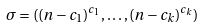Convert formula to latex. <formula><loc_0><loc_0><loc_500><loc_500>\sigma = ( ( n - c _ { 1 } ) ^ { c _ { 1 } } , \dots , ( n - c _ { k } ) ^ { c _ { k } } )</formula> 